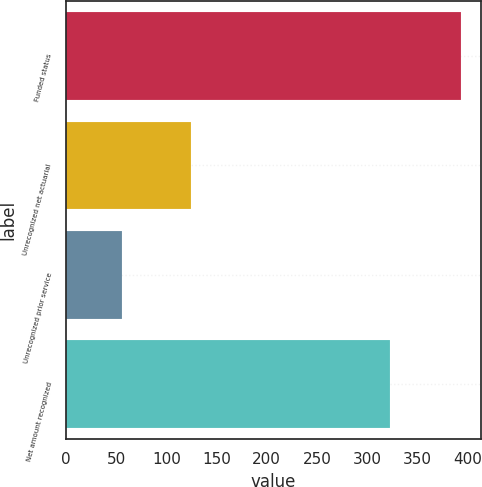Convert chart. <chart><loc_0><loc_0><loc_500><loc_500><bar_chart><fcel>Funded status<fcel>Unrecognized net actuarial<fcel>Unrecognized prior service<fcel>Net amount recognized<nl><fcel>394<fcel>125<fcel>56<fcel>323<nl></chart> 